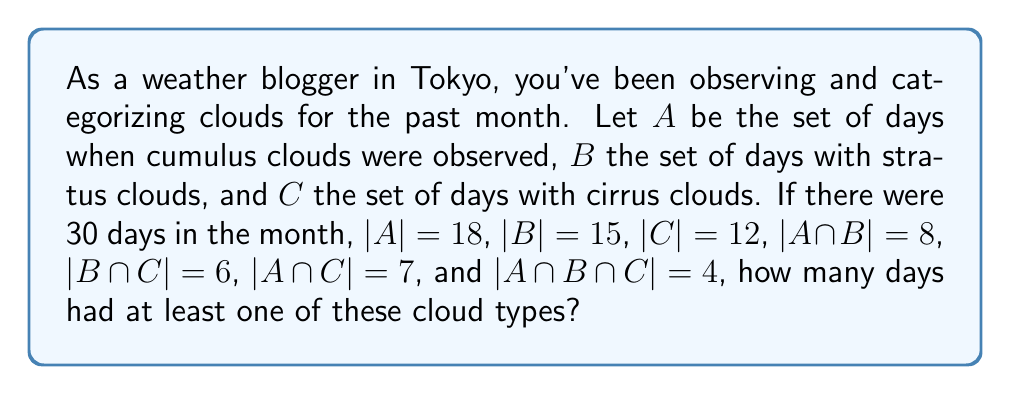Could you help me with this problem? To solve this problem, we'll use the Inclusion-Exclusion Principle for three sets:

$$|A \cup B \cup C| = |A| + |B| + |C| - |A \cap B| - |B \cap C| - |A \cap C| + |A \cap B \cap C|$$

Let's substitute the given values:

$$|A \cup B \cup C| = 18 + 15 + 12 - 8 - 6 - 7 + 4$$

Now, let's calculate step by step:

1) First, add the individual set cardinalities:
   $18 + 15 + 12 = 45$

2) Then, subtract the intersections of two sets:
   $45 - 8 - 6 - 7 = 24$

3) Finally, add back the intersection of all three sets:
   $24 + 4 = 28$

Therefore, there were 28 days with at least one of these cloud types observed.
Answer: 28 days 